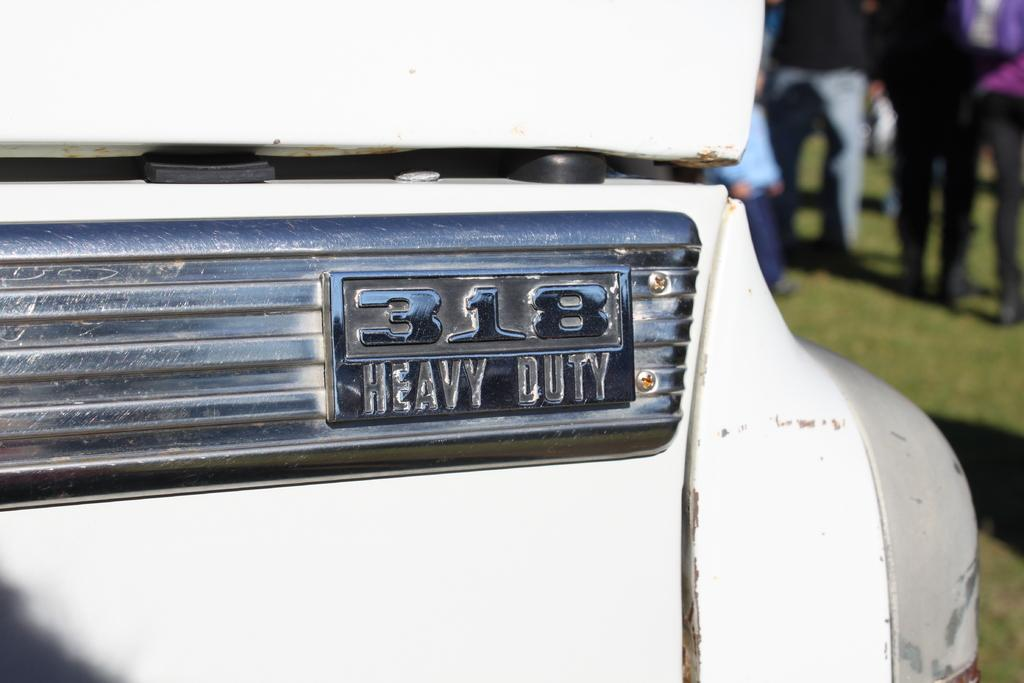What is the main subject of the image? There is a vehicle in the image. Can you describe the background of the image? The background of the image is blurry. Are there any other elements present in the image besides the vehicle? Yes, there are people visible in the image. What type of health advice can be seen on the sign at the zoo in the image? There is no sign or zoo present in the image; it features a vehicle and people in a blurry background. 